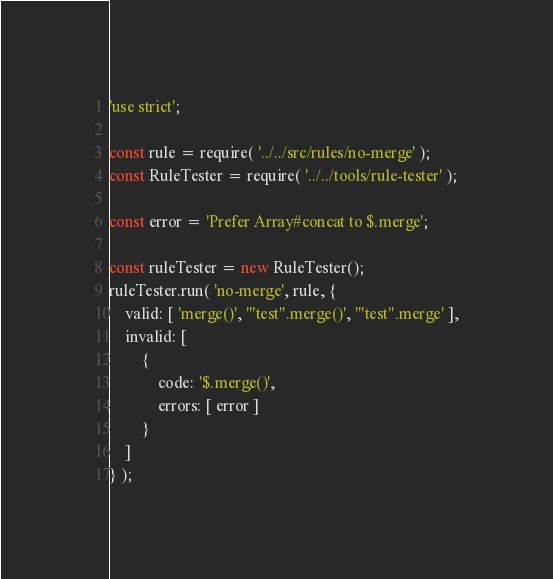<code> <loc_0><loc_0><loc_500><loc_500><_JavaScript_>'use strict';

const rule = require( '../../src/rules/no-merge' );
const RuleTester = require( '../../tools/rule-tester' );

const error = 'Prefer Array#concat to $.merge';

const ruleTester = new RuleTester();
ruleTester.run( 'no-merge', rule, {
	valid: [ 'merge()', '"test".merge()', '"test".merge' ],
	invalid: [
		{
			code: '$.merge()',
			errors: [ error ]
		}
	]
} );
</code> 